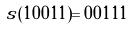<formula> <loc_0><loc_0><loc_500><loc_500>s ( 1 0 0 1 1 ) = 0 0 1 1 1</formula> 